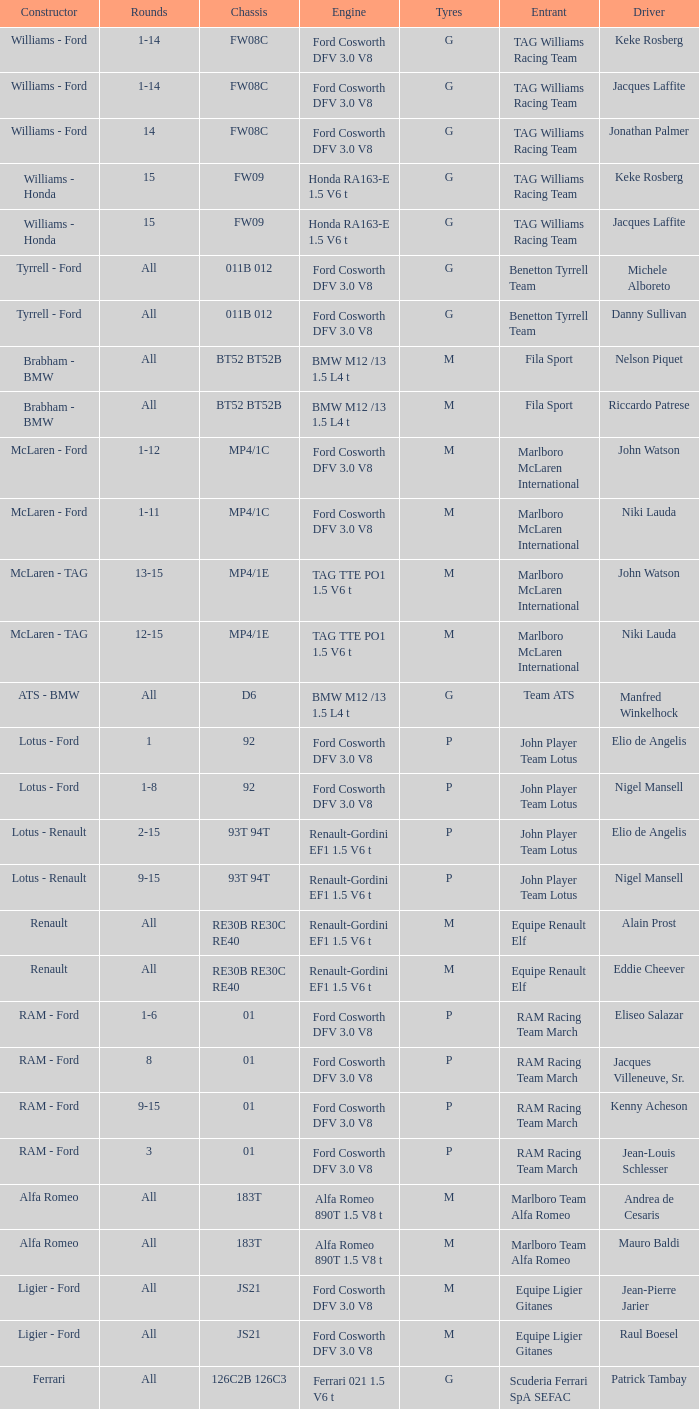Who is the constructor for driver Niki Lauda and a chassis of mp4/1c? McLaren - Ford. 